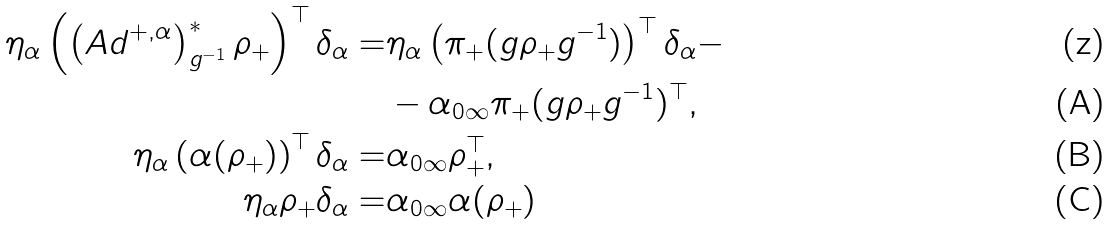Convert formula to latex. <formula><loc_0><loc_0><loc_500><loc_500>\eta _ { \alpha } \left ( \left ( A d ^ { + , \alpha } \right ) ^ { * } _ { g ^ { - 1 } } \rho _ { + } \right ) ^ { \top } \delta _ { \alpha } = & \eta _ { \alpha } \left ( \pi _ { + } ( g \rho _ { + } g ^ { - 1 } ) \right ) ^ { \top } \delta _ { \alpha } - \\ & - \alpha _ { 0 \infty } \pi _ { + } ( g \rho _ { + } g ^ { - 1 } ) ^ { \top } , \\ \eta _ { \alpha } \left ( \alpha ( \rho _ { + } ) \right ) ^ { \top } \delta _ { \alpha } = & \alpha _ { 0 \infty } \rho _ { + } ^ { \top } , \\ \eta _ { \alpha } \rho _ { + } \delta _ { \alpha } = & \alpha _ { 0 \infty } \alpha ( \rho _ { + } )</formula> 